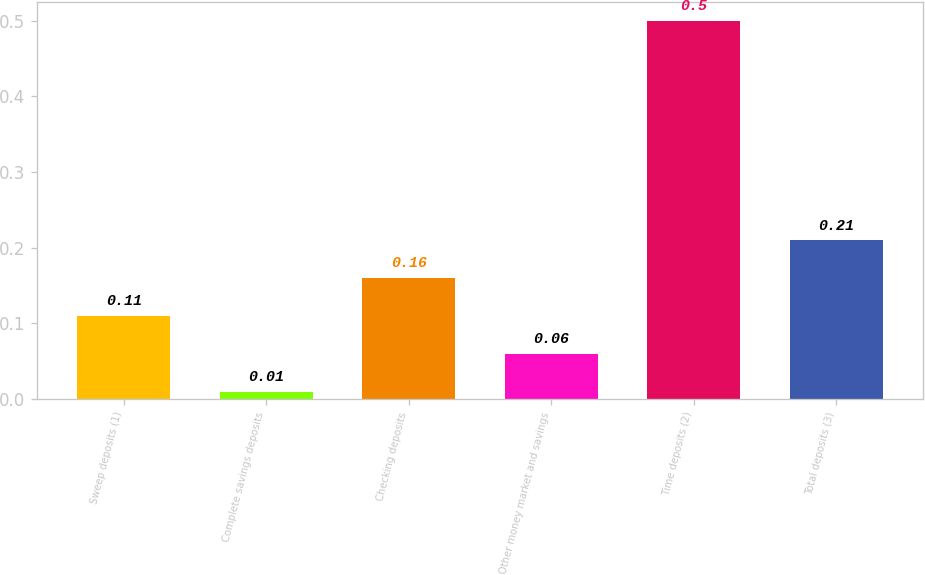Convert chart to OTSL. <chart><loc_0><loc_0><loc_500><loc_500><bar_chart><fcel>Sweep deposits (1)<fcel>Complete savings deposits<fcel>Checking deposits<fcel>Other money market and savings<fcel>Time deposits (2)<fcel>Total deposits (3)<nl><fcel>0.11<fcel>0.01<fcel>0.16<fcel>0.06<fcel>0.5<fcel>0.21<nl></chart> 